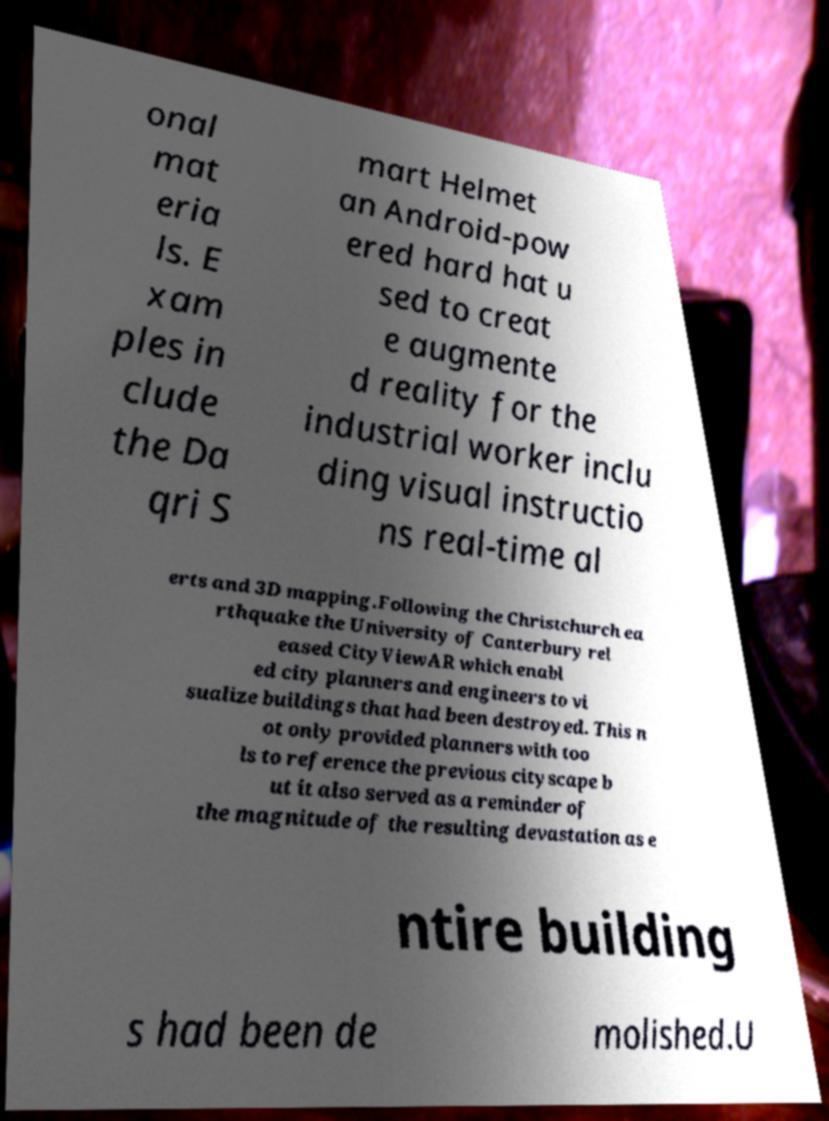Could you extract and type out the text from this image? onal mat eria ls. E xam ples in clude the Da qri S mart Helmet an Android-pow ered hard hat u sed to creat e augmente d reality for the industrial worker inclu ding visual instructio ns real-time al erts and 3D mapping.Following the Christchurch ea rthquake the University of Canterbury rel eased CityViewAR which enabl ed city planners and engineers to vi sualize buildings that had been destroyed. This n ot only provided planners with too ls to reference the previous cityscape b ut it also served as a reminder of the magnitude of the resulting devastation as e ntire building s had been de molished.U 